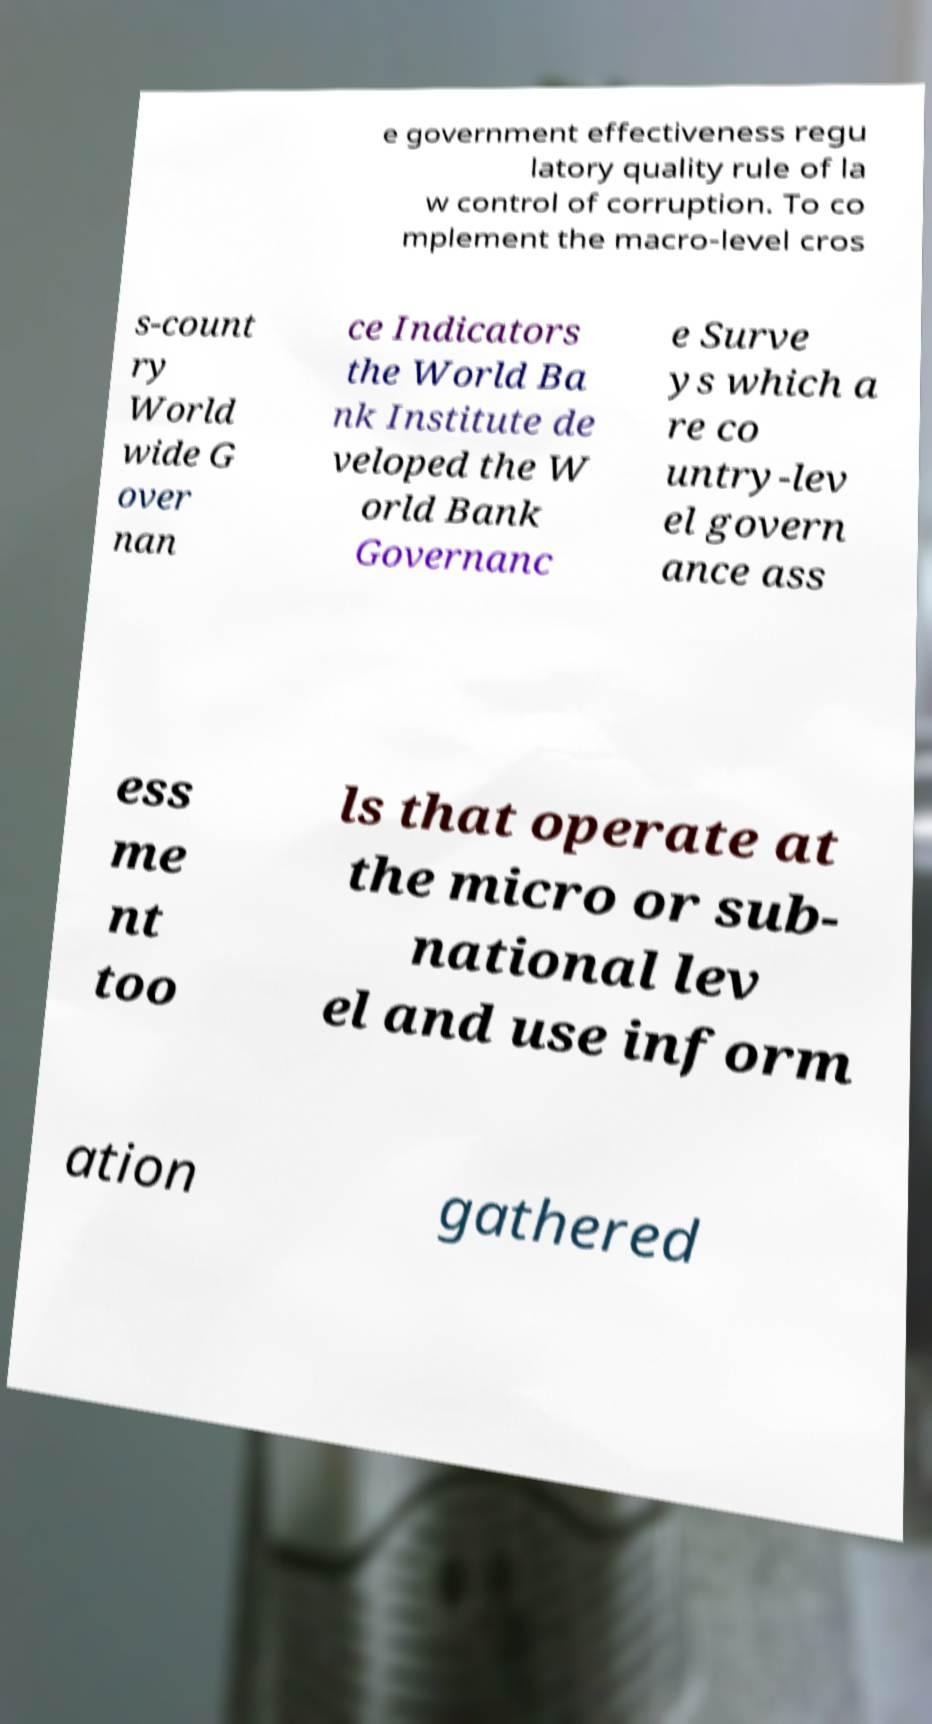For documentation purposes, I need the text within this image transcribed. Could you provide that? e government effectiveness regu latory quality rule of la w control of corruption. To co mplement the macro-level cros s-count ry World wide G over nan ce Indicators the World Ba nk Institute de veloped the W orld Bank Governanc e Surve ys which a re co untry-lev el govern ance ass ess me nt too ls that operate at the micro or sub- national lev el and use inform ation gathered 